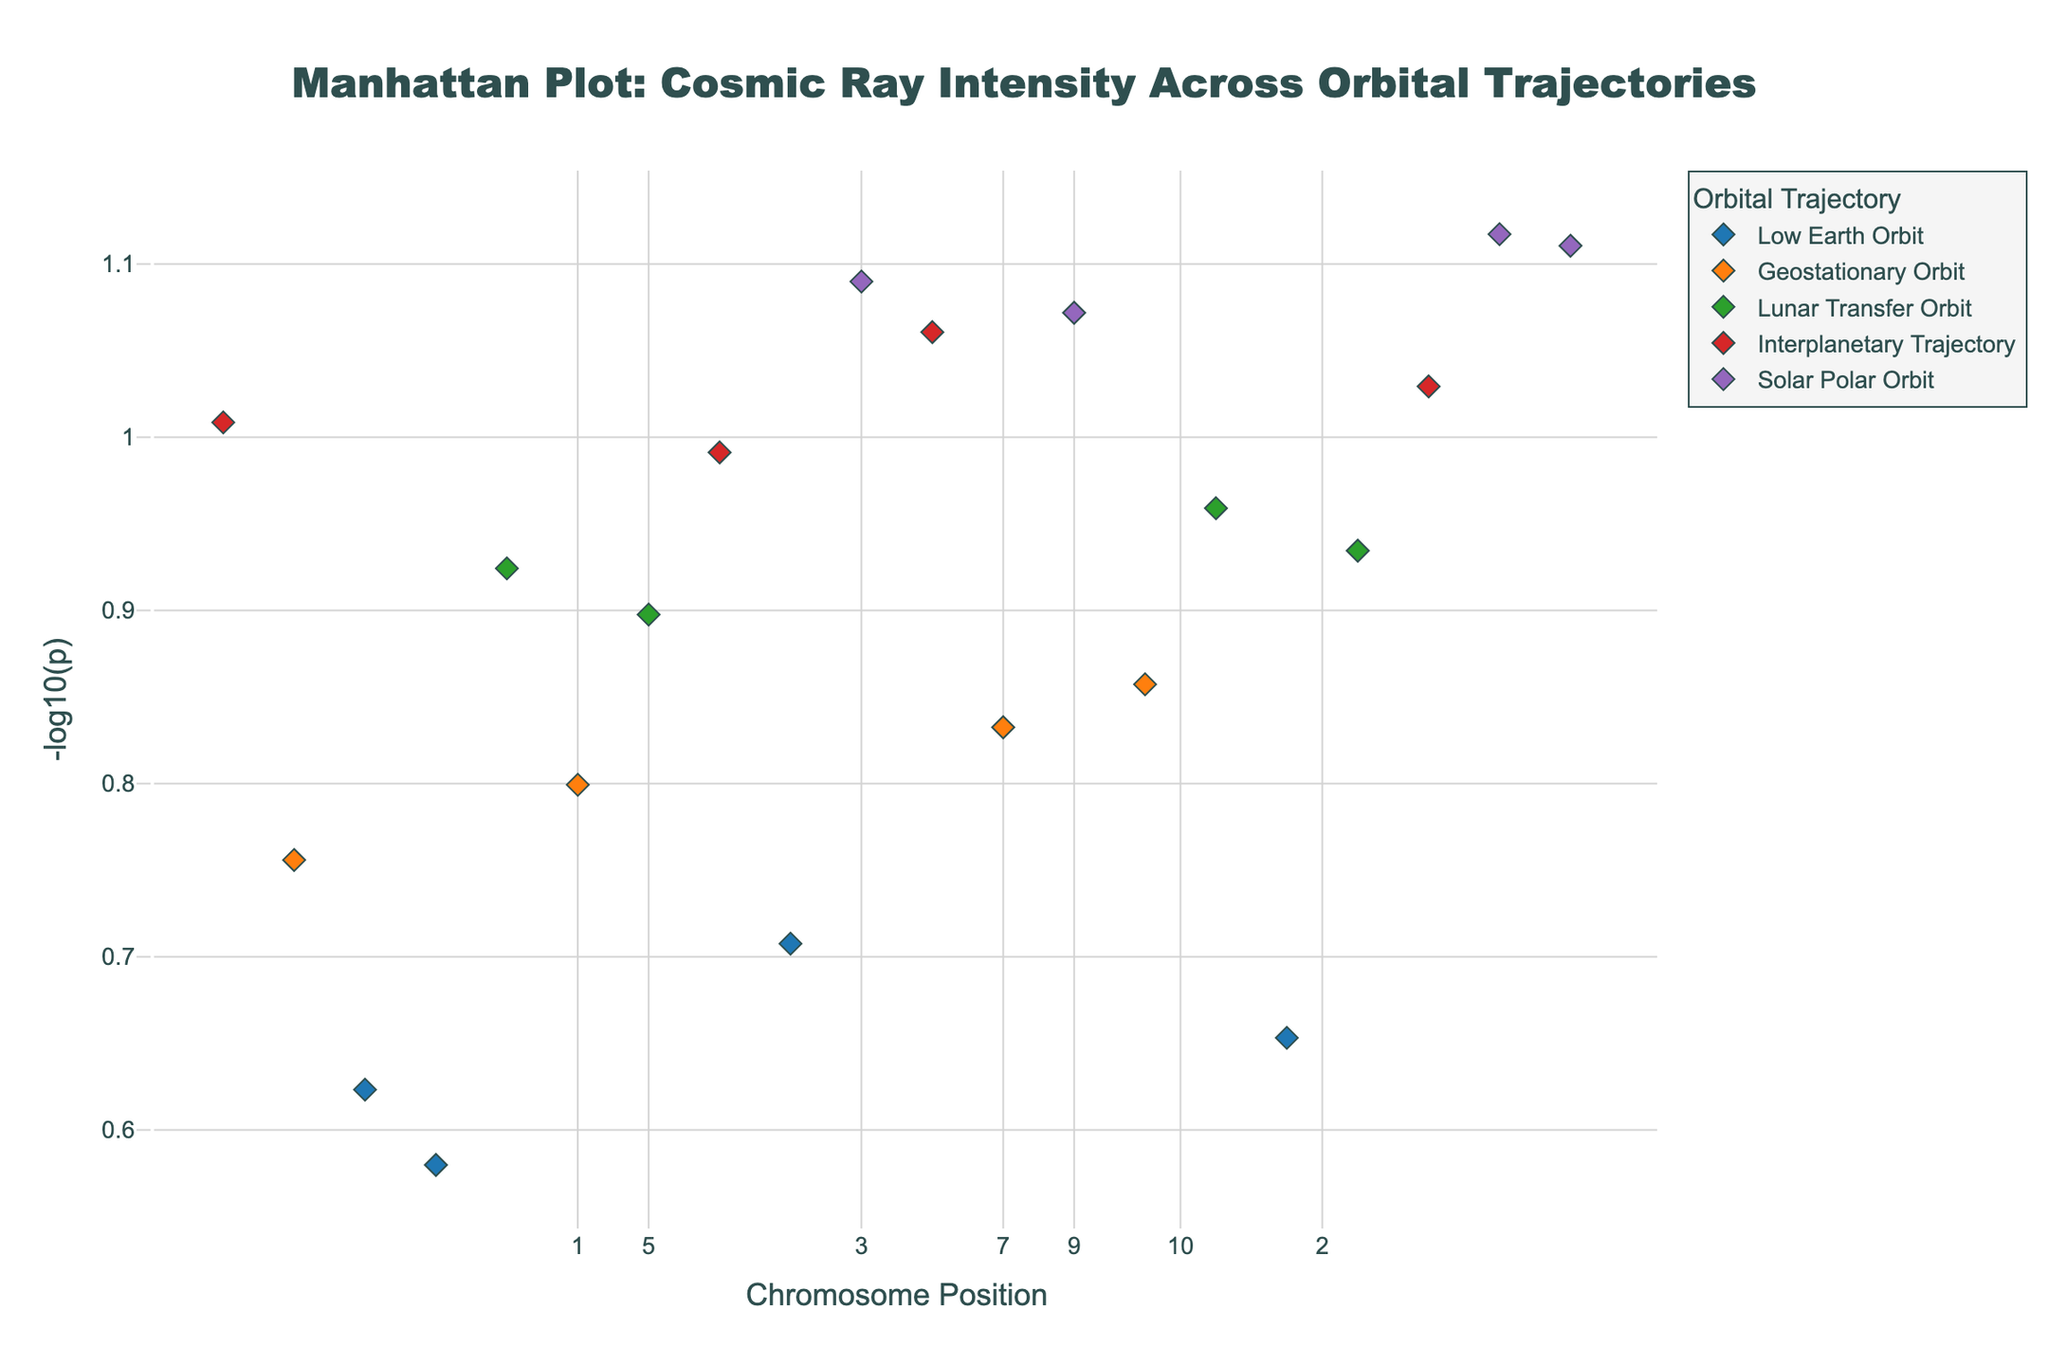What's the title of the figure? The title is usually displayed at the top of the figure within the layout settings. It provides a quick summary of what the plot represents. In this case, it's "Manhattan Plot: Cosmic Ray Intensity Across Orbital Trajectories".
Answer: "Manhattan Plot: Cosmic Ray Intensity Across Orbital Trajectories" What is the y-axis label? The y-axis label is typically shown alongside the y-axis to provide context to the data being plotted. Here, the label is "-log10(p)", indicating the transformation applied to the intensity data.
Answer: -log10(p) Which trajectory has the highest intensity value? To find this, we need to identify which trajectory corresponds to the highest y-value in the figure. From the hover text and data, the highest intensity is for the "Solar Polar Orbit" with an intensity (log-transformed) of 13.1.
Answer: Solar Polar Orbit How are the different trajectories visually distinguished in the plot? Different trajectories are often distinguished by various colors and possibly symbols in a plot to aid in clarity. Here, each trajectory has a unique color, and diamond markers are used to represent the data points.
Answer: Different colors Which chromosome has the highest average -log10(p) value across all trajectories? To determine the chromosome with the highest average -log10(p), calculate the mean -log10(p) for each chromosome and then compare them. Chromosome 9 has the highest average with values of 12.3 and 13.1.
Answer: Chromosome 9 Compare the -log10(p) values of `Interplanetary Trajectory`, which chromosome (positions) has the highest value? Within 'Interplanetary Trajectory,' compare the y-values of positions on different chromosomes. Positions on chromosome 8 have the highest value of 10.7.
Answer: Chromosome 8 What trend do you observe in the -log10(p) values as we move from lower orbital altitudes to higher ones? Observing the progression of -log10(p) values from lower to higher orbits, there is a clear trend of increasing -log10(p) values, signifying that cosmic ray intensity gets higher with increasing orbital altitude.
Answer: Increasing trend How many unique trajectories are represented in the figure? The number of distinct trajectories can be counted by looking at the labels in the legend. There are five unique trajectories: Low Earth Orbit, Geostationary Orbit, Lunar Transfer Orbit, Interplanetary Trajectory, and Solar Polar Orbit.
Answer: Five What does the color of a marker represent in this Manhattan plot? In the plot, the color of each marker represents the trajectory or orbit type. Different colors are used to distinguish between Low Earth Orbit, Geostationary Orbit, Lunar Transfer Orbit, Interplanetary Trajectory, and Solar Polar Orbit.
Answer: Trajectory type Is there a correlation between chromosome number and -log10(p) values? Correlation can be observed by examining the spread of `-log10(p)` values across different chromosomes. No clear correlation is evident, as high and low values are scattered across various chromosomes.
Answer: No clear correlation 